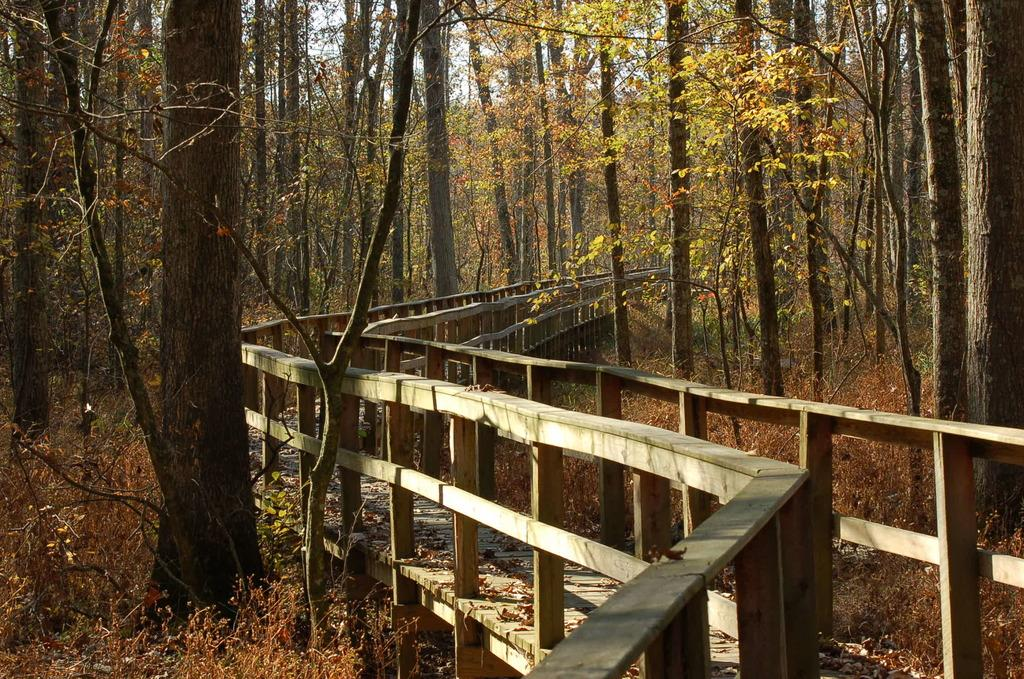What is the main structure in the middle of the image? There is a bridge in the middle of the image. What type of barriers can be seen in the image? There are fences in the image. What type of vegetation is present on either side of the bridge? Trees are present on either side of the bridge. What type of ground cover can be seen in the image? Plants are visible on the ground. What is visible in the background of the image? The sky is visible in the background of the image. What type of account can be seen in the image? There is no account present in the image; it features a bridge, fences, trees, plants, and the sky. What type of hospital can be seen in the image? There is no hospital present in the image; it features a bridge, fences, trees, plants, and the sky. 